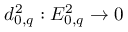<formula> <loc_0><loc_0><loc_500><loc_500>d _ { 0 , q } ^ { 2 } \colon E _ { 0 , q } ^ { 2 } \to 0</formula> 